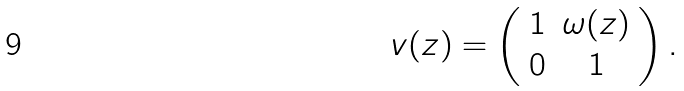<formula> <loc_0><loc_0><loc_500><loc_500>v ( z ) = \left ( \begin{array} { c c } 1 & \omega ( z ) \\ 0 & 1 \end{array} \right ) .</formula> 